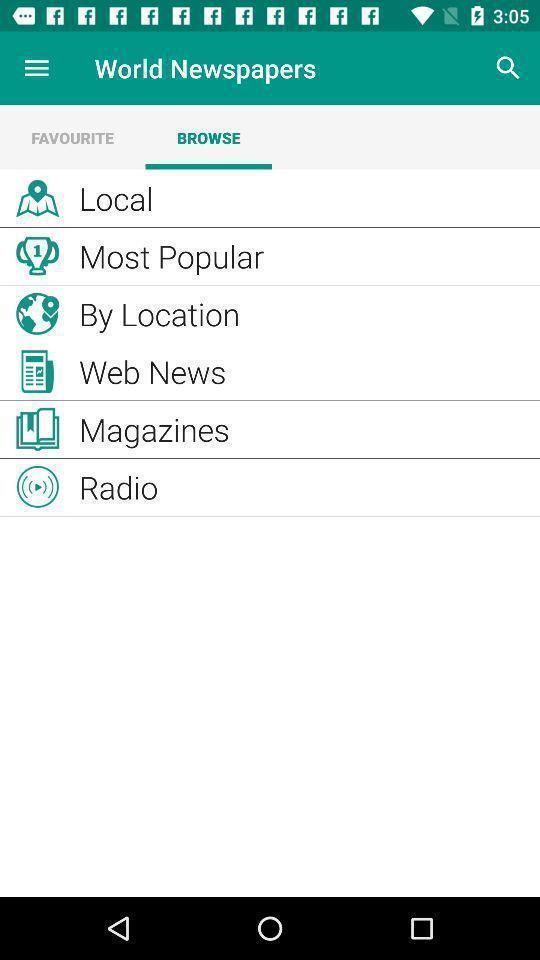Provide a detailed account of this screenshot. Page showing options in a news related app. 